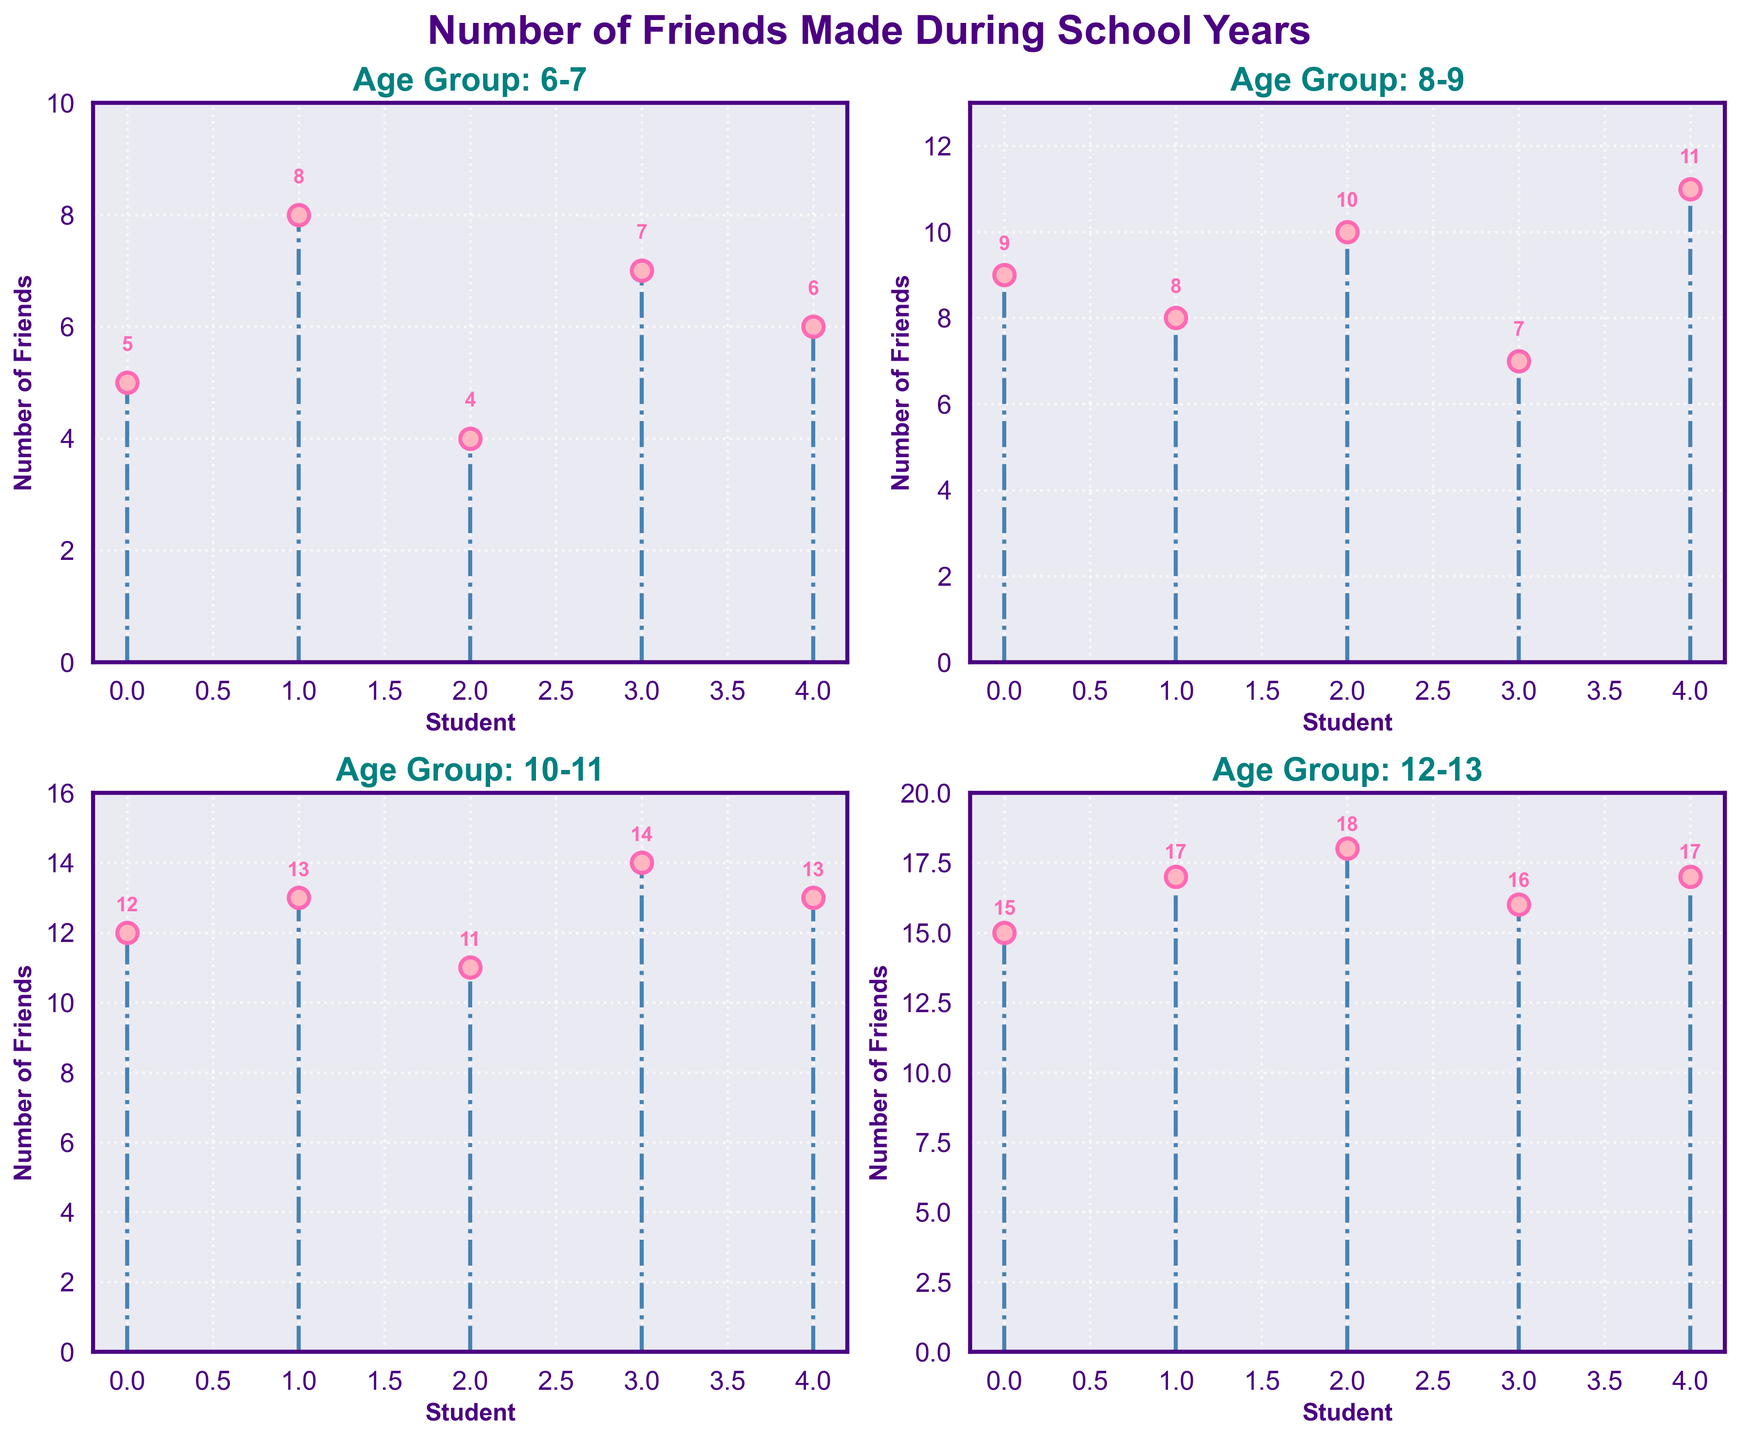How many age groups are represented in the figure? The figure's subplots represent different age groups, which are indicated by the titles of each subplot. By counting the number of distinct subplot titles, we can determine the number of age groups.
Answer: 4 Which age group has a stem plot with the highest maximum number of friends made by any student? To find which age group has the highest number of friends made by any student, we locate the highest data point in each subplot and compare them: Age 6-7 has a maximum of 8, Age 8-9 has 11, Age 10-11 has 14, and Age 12-13 reaches 18.
Answer: 12-13 What is the average number of friends made for the group aged 8-9? First, sum the number of friends made by each student in the 8-9 age group: 9 + 8 + 10 + 7 + 11 = 45. Then, divide by the number of data points (5): 45 / 5.
Answer: 9 Compare the lowest number of friends made in the 6-7 age group and the 8-9 age group. Which group has a lower minimum value? Identify the lowest value in each group: For 6-7 age group it is 4, and for 8-9 age group it is 7. The group with the lower minimum is the 6-7 age group.
Answer: 6-7 How many students in age group 10-11 made more than 12 friends? Count the data points above 12 in the 10-11 age group stem plot. There are 13, 14, and 13, so three students made more than 12 friends.
Answer: 3 What is the total number of friends made by students in the 12-13 age group? Sum the number of friends: 15 + 17 + 18 + 16 + 17 = 83.
Answer: 83 Compare the totals of friends made in the age groups 6-7 and 8-9. Which age group has a larger total number of friends made? Calculate the sums for both groups: 6-7 total is 5 + 8 + 4 + 7 + 6 = 30, and 8-9 total is 9 + 8 + 10 + 7 + 11 = 45. The 8-9 age group has a larger total.
Answer: 8-9 In the 10-11 age group, what is the median number of friends made? Arrange the values in ascending order: 11, 12, 13, 13, 14. The median, which is the middle value in the sorted list, is 13.
Answer: 13 Which subplot has the most consistent range of friends made (smallest difference between maximum and minimum number of friends)? Calculate the range for each group: 6-7: 8-4=4, 8-9: 11-7=4, 10-11: 14-11=3, 12-13: 18-15=3. The smallest range (3) occurs in both 10-11 and 12-13 groups.
Answer: 10-11, 12-13 